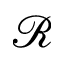Convert formula to latex. <formula><loc_0><loc_0><loc_500><loc_500>\ m a t h s c r { R }</formula> 